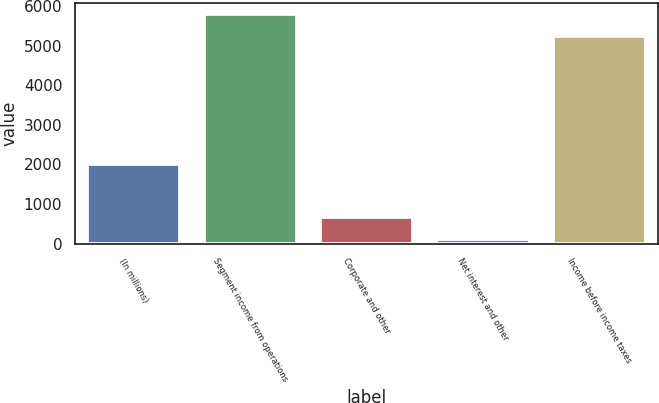<chart> <loc_0><loc_0><loc_500><loc_500><bar_chart><fcel>(In millions)<fcel>Segment income from operations<fcel>Corporate and other<fcel>Net interest and other<fcel>Income before income taxes<nl><fcel>2012<fcel>5789.5<fcel>660.5<fcel>109<fcel>5238<nl></chart> 